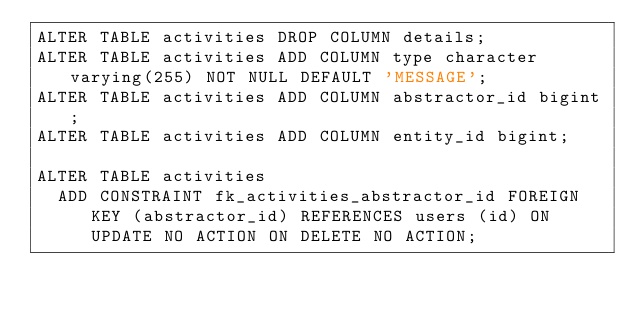Convert code to text. <code><loc_0><loc_0><loc_500><loc_500><_SQL_>ALTER TABLE activities DROP COLUMN details;
ALTER TABLE activities ADD COLUMN type character varying(255) NOT NULL DEFAULT 'MESSAGE';
ALTER TABLE activities ADD COLUMN abstractor_id bigint;
ALTER TABLE activities ADD COLUMN entity_id bigint;

ALTER TABLE activities
  ADD CONSTRAINT fk_activities_abstractor_id FOREIGN KEY (abstractor_id) REFERENCES users (id) ON UPDATE NO ACTION ON DELETE NO ACTION;</code> 